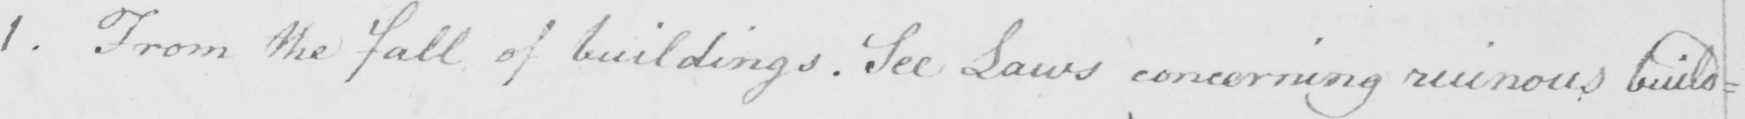What does this handwritten line say? 1 . From the fall of buildings . See Laws concerning ruinous build : 